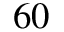Convert formula to latex. <formula><loc_0><loc_0><loc_500><loc_500>6 0</formula> 